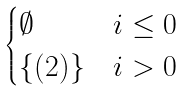Convert formula to latex. <formula><loc_0><loc_0><loc_500><loc_500>\begin{cases} \emptyset & i \leq 0 \\ \{ ( 2 ) \} & i > 0 \end{cases}</formula> 